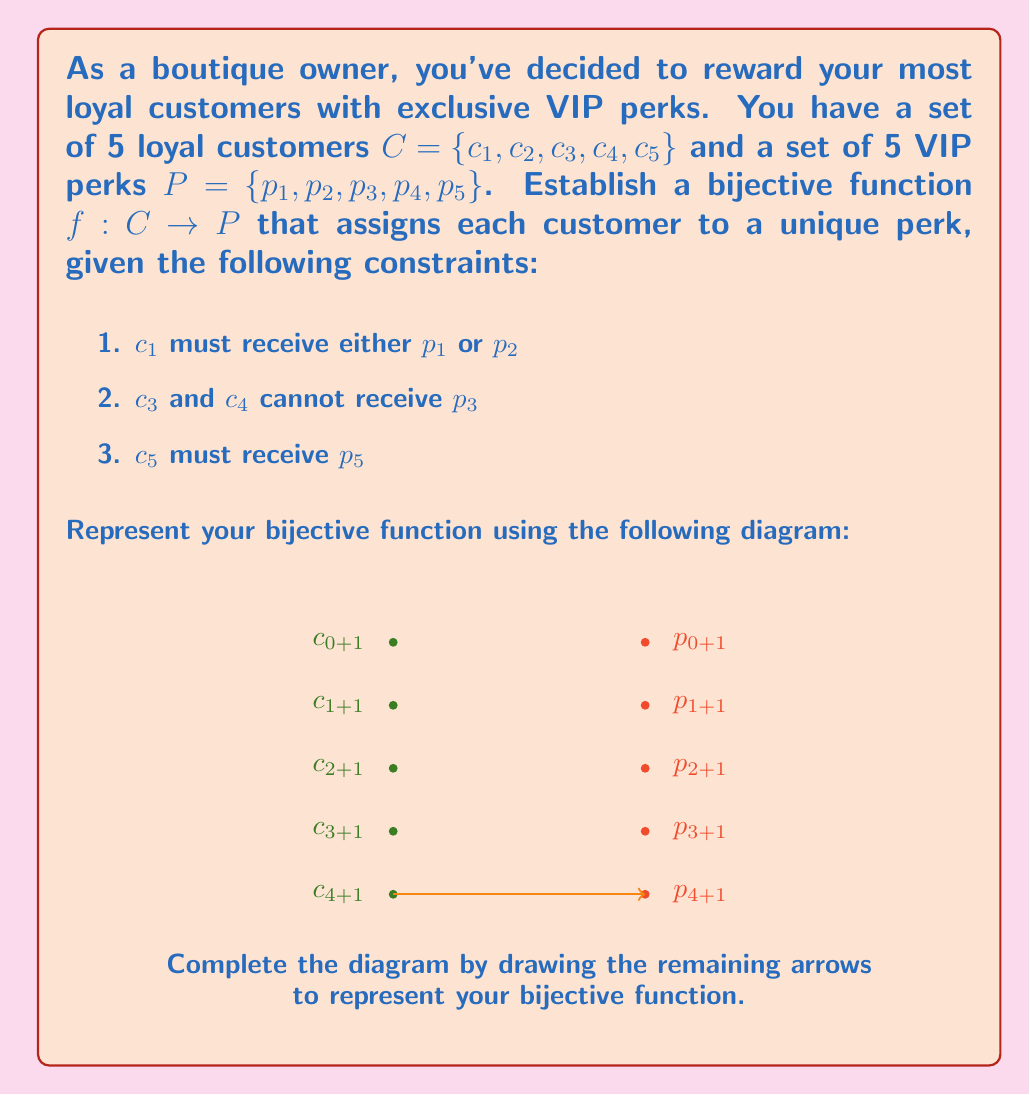Provide a solution to this math problem. To establish a bijective function between sets $C$ and $P$, we need to create a one-to-one correspondence that satisfies the given constraints. Let's approach this step-by-step:

1. We start with $c_5$, which must receive $p_5$. This satisfies the third constraint:
   $f(c_5) = p_5$

2. For $c_1$, we have two options: $p_1$ or $p_2$. Let's choose $p_1$:
   $f(c_1) = p_1$

3. Now, $c_3$ and $c_4$ cannot receive $p_3$. We have $p_2$ and $p_4$ available for them. Let's assign:
   $f(c_3) = p_4$
   $f(c_4) = p_2$

4. The only customer left is $c_2$, and the only perk left is $p_3$:
   $f(c_2) = p_3$

This assignment satisfies all the constraints and creates a one-to-one correspondence between $C$ and $P$. Each customer is assigned a unique perk, and each perk is assigned to a unique customer.

The complete bijective function can be represented as:

$$f = \{(c_1, p_1), (c_2, p_3), (c_3, p_4), (c_4, p_2), (c_5, p_5)\}$$

To complete the diagram, we would draw arrows from each $c_i$ to its corresponding $p_j$ according to the function $f$.
Answer: $f = \{(c_1, p_1), (c_2, p_3), (c_3, p_4), (c_4, p_2), (c_5, p_5)\}$ 